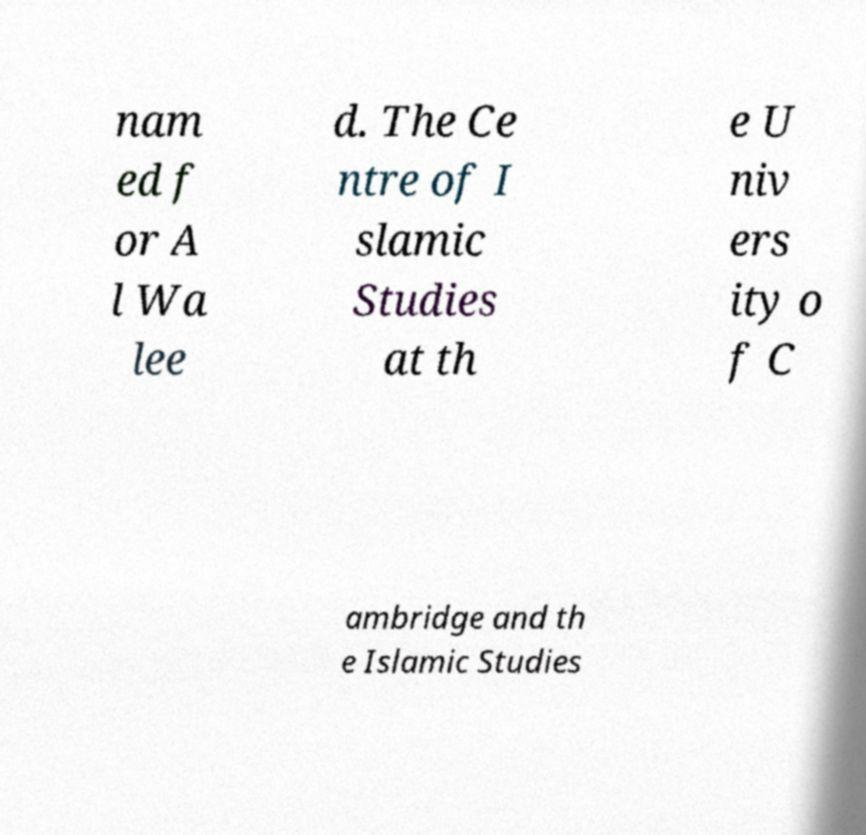Could you extract and type out the text from this image? nam ed f or A l Wa lee d. The Ce ntre of I slamic Studies at th e U niv ers ity o f C ambridge and th e Islamic Studies 